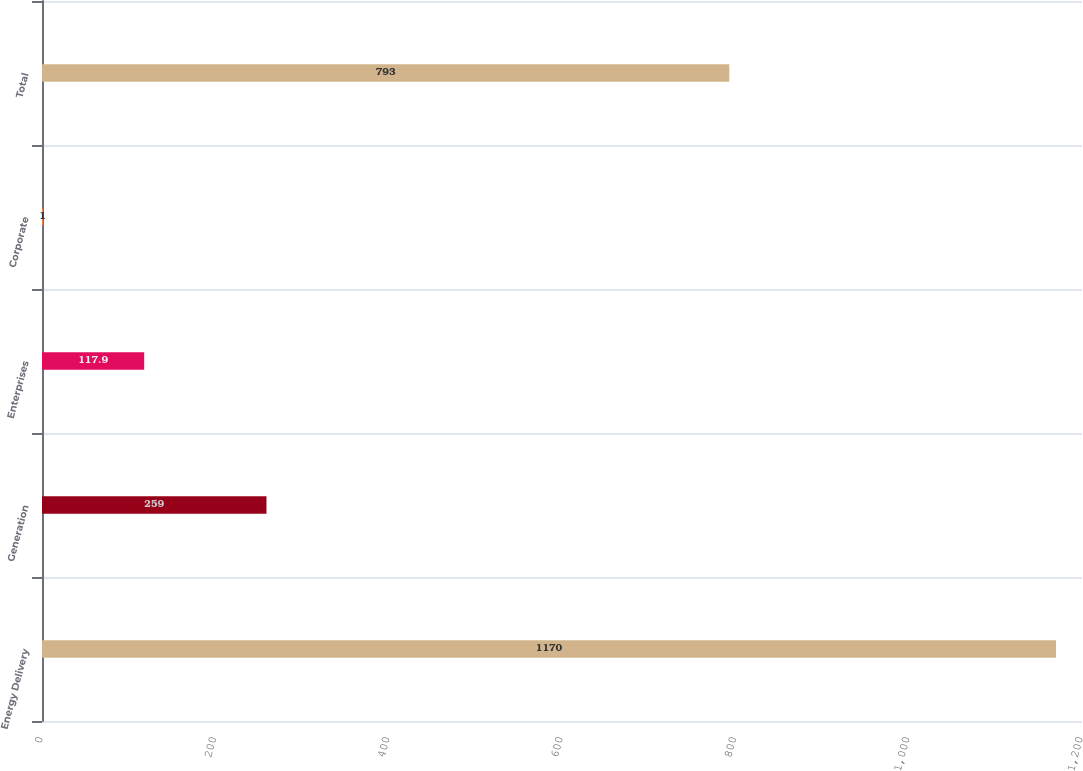Convert chart to OTSL. <chart><loc_0><loc_0><loc_500><loc_500><bar_chart><fcel>Energy Delivery<fcel>Generation<fcel>Enterprises<fcel>Corporate<fcel>Total<nl><fcel>1170<fcel>259<fcel>117.9<fcel>1<fcel>793<nl></chart> 